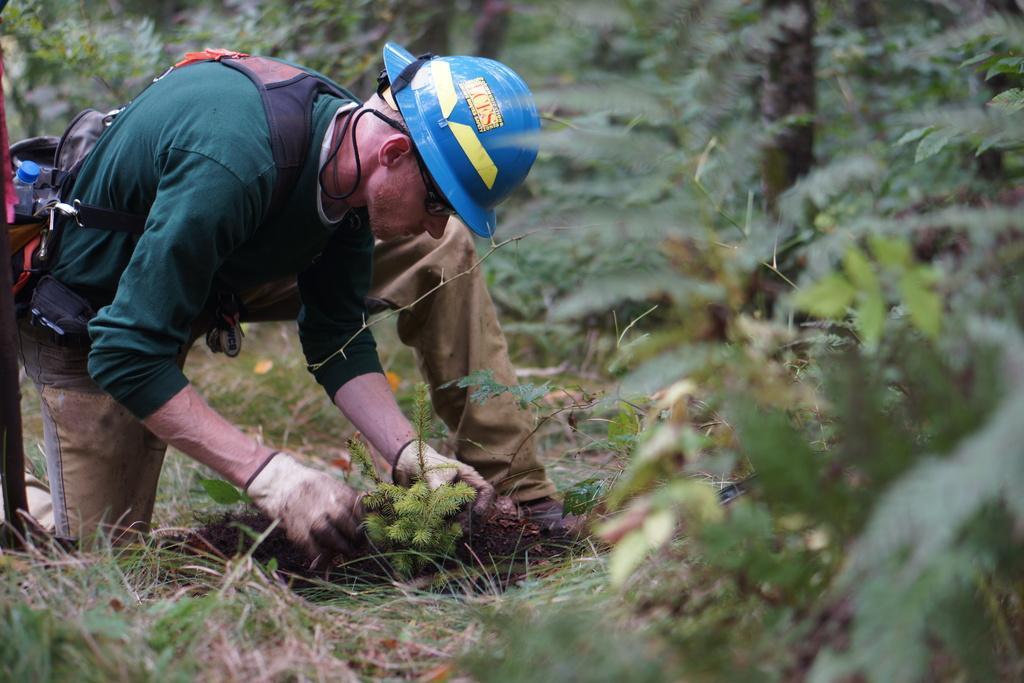Please provide a concise description of this image. In this picture we can observe a person wearing green color T shirt and a blue color helmet on his head. He is wearing gloves and holding a plant in his hands. We can observe some plants in the background. 